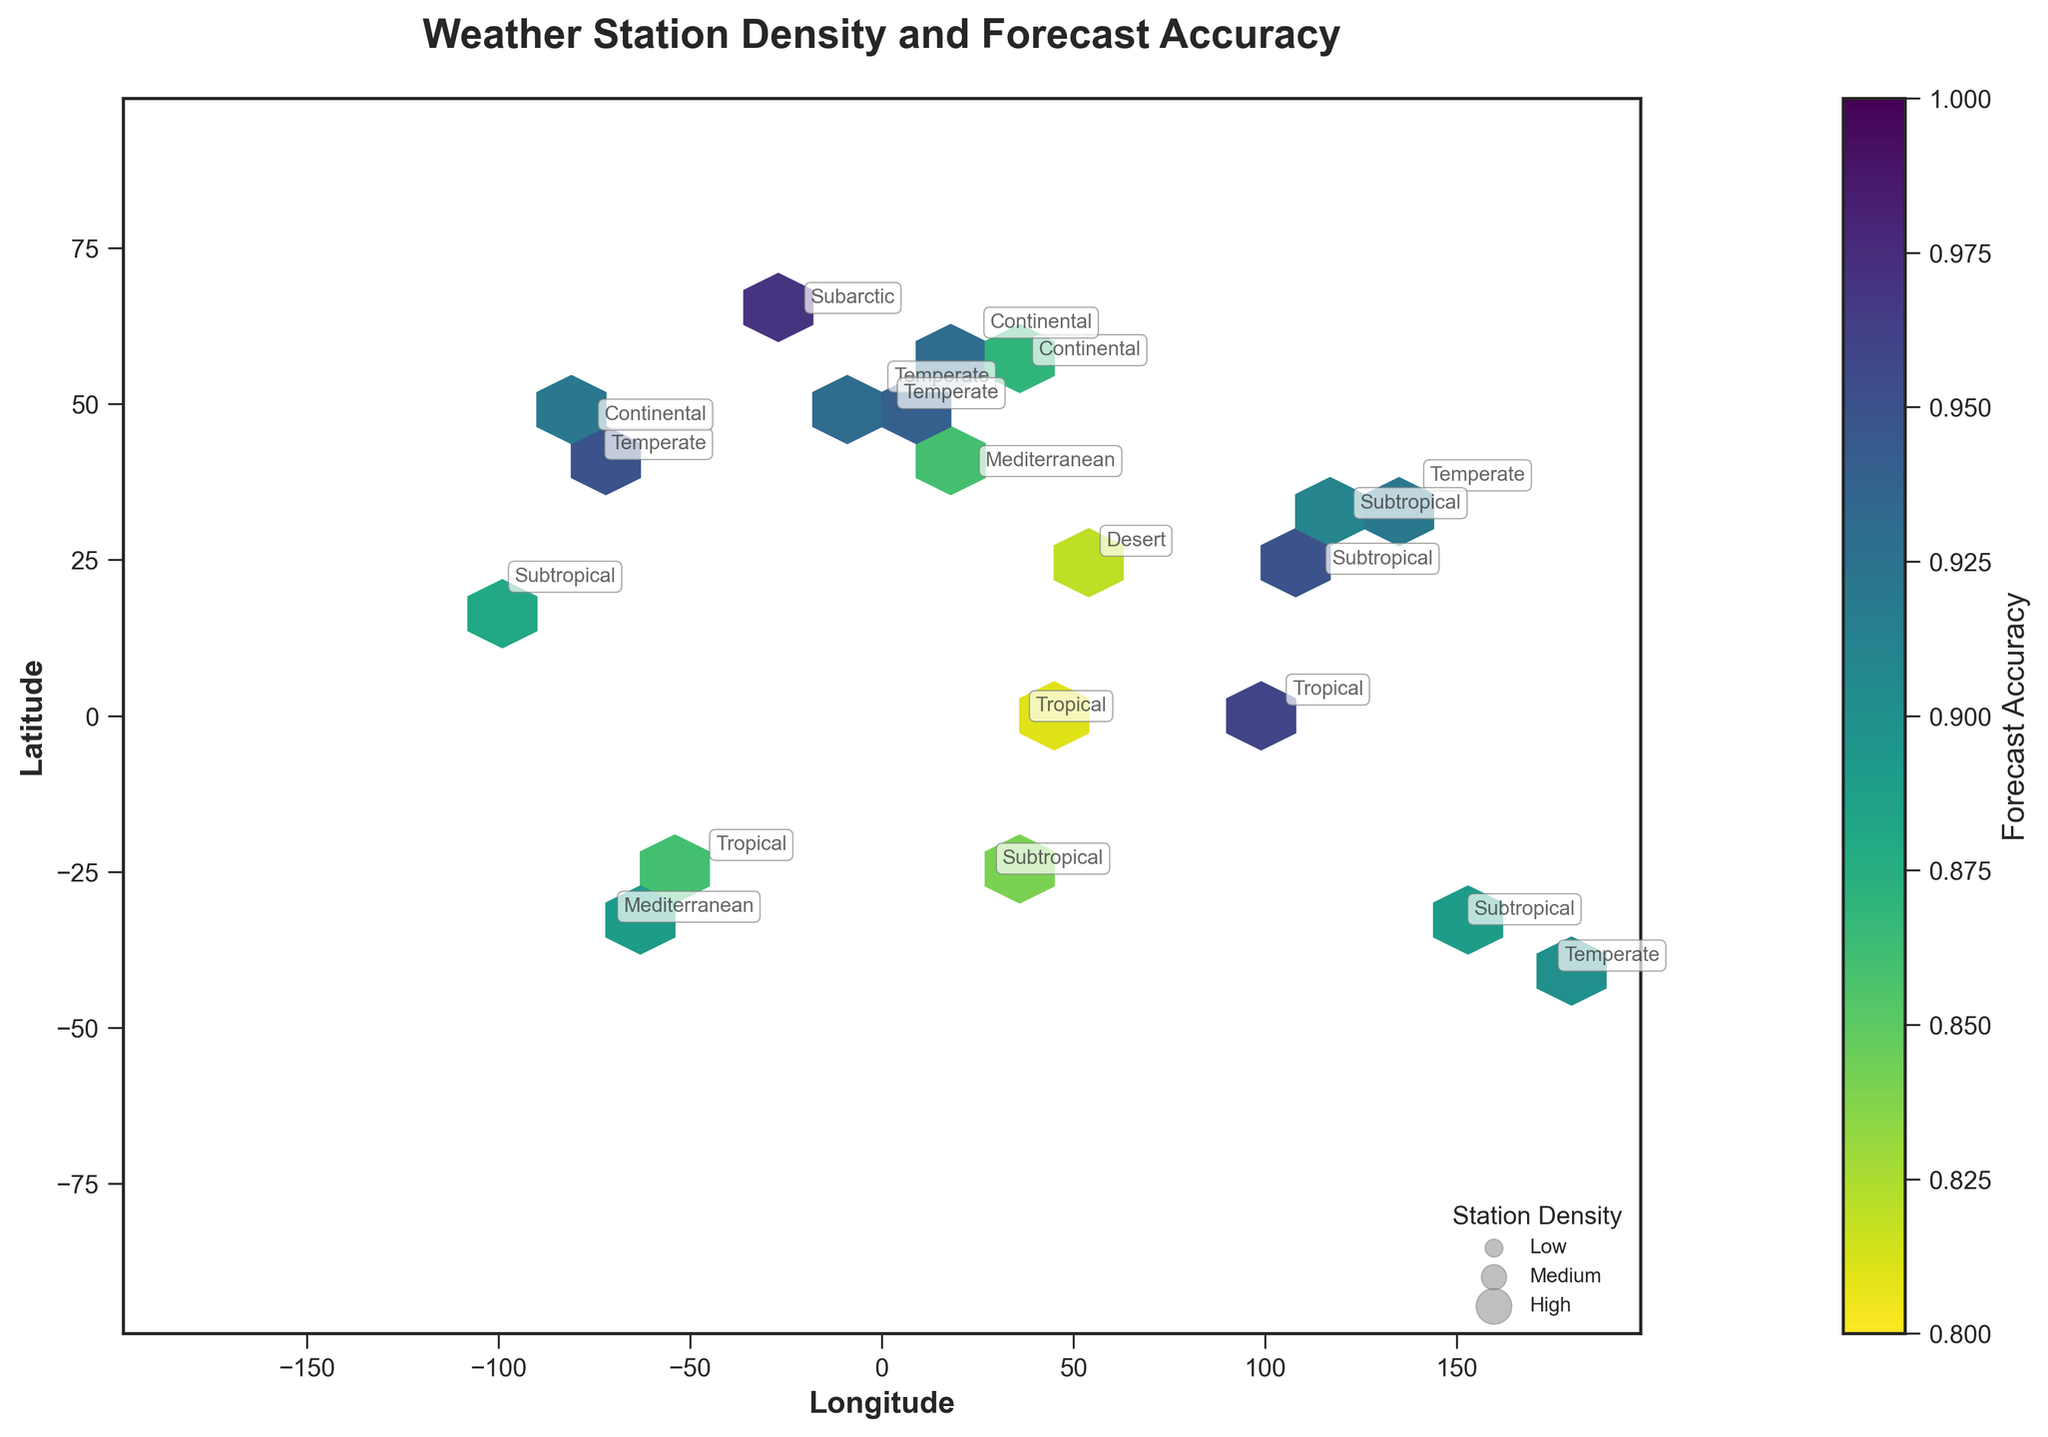What is the title of the plot? The title is located at the top center of the plot and is usually written in a larger font size and bold style. Here, it is "Weather Station Density and Forecast Accuracy".
Answer: Weather Station Density and Forecast Accuracy What is the average forecast accuracy for tropical climate zones indicated in the plot? By looking at the text annotations on the plot, tropical climate zones are marked. The forecast accuracies for tropical climate zones are 0.86, 0.96, and 0.81. The average is calculated as (0.86 + 0.96 + 0.81) / 3.
Answer: 0.877 Which climate zone has the highest forecast accuracy? The color bar shows forecast accuracy ranging from 0.8 to 1.0 with darker colors indicating higher accuracy. By observing the shades and text annotations, the Subarctic climate zone has the forecast accuracy of 0.97, which is the highest.
Answer: Subarctic How many climate zones are there in the plot? By counting the number of unique 'climate_zone' labels visible in the annotations, which include Temperate, Subtropical, Continental, Tropical, Subarctic, Desert, and Mediterranean.
Answer: Seven What is the forecast accuracy in the Continental climate zone near the coordinates (60.1699, 24.9384)? By referring to the text annotation at the specific coordinates marked on the plot, the forecast accuracy is 0.93.
Answer: 0.93 Which climate zone has the lowest station density, and what is their forecast accuracy? By comparing the station densities indicated in the legend and text annotations, the Desert climate zone has the lowest station density of 5. Its forecast accuracy is annotated as 0.82.
Answer: Desert, 0.82 Compare the forecast accuracy between the Temperate and Temperate climate zones. Which one is higher? By checking the text annotations for both climate zones, Temperate has values such as 0.92, 0.95, 0.90, and 0.94. While Subarctic has 0.97 which is higher than the highest value in Temperate.
Answer: Subarctic Is there a clear trend between station density and forecast accuracy visible in the plot? Observing the plot, it appears that areas with higher station densities generally show higher forecast accuracies, as seen with darker shades in denser regions. However, a definitive trend would require statistical analysis beyond visual inspection.
Answer: Generally yes What's the forecast accuracy for the weather station in Subtropical climate zone near (31.2304, 121.4737)? The text annotation next to the coordinates in the Subtropical climate zone near (31.2304, 121.4737) shows a forecast accuracy of 0.91.
Answer: 0.91 Which region has a forecast accuracy close to 0.95? By checking the color code against the color bar for values close to 0.95 and referring to text annotations, areas like Temperate (e.g., New York) and Subtropical (e.g., Hong Kong) have forecast accuracies of 0.95.
Answer: New York, Hong Kong 